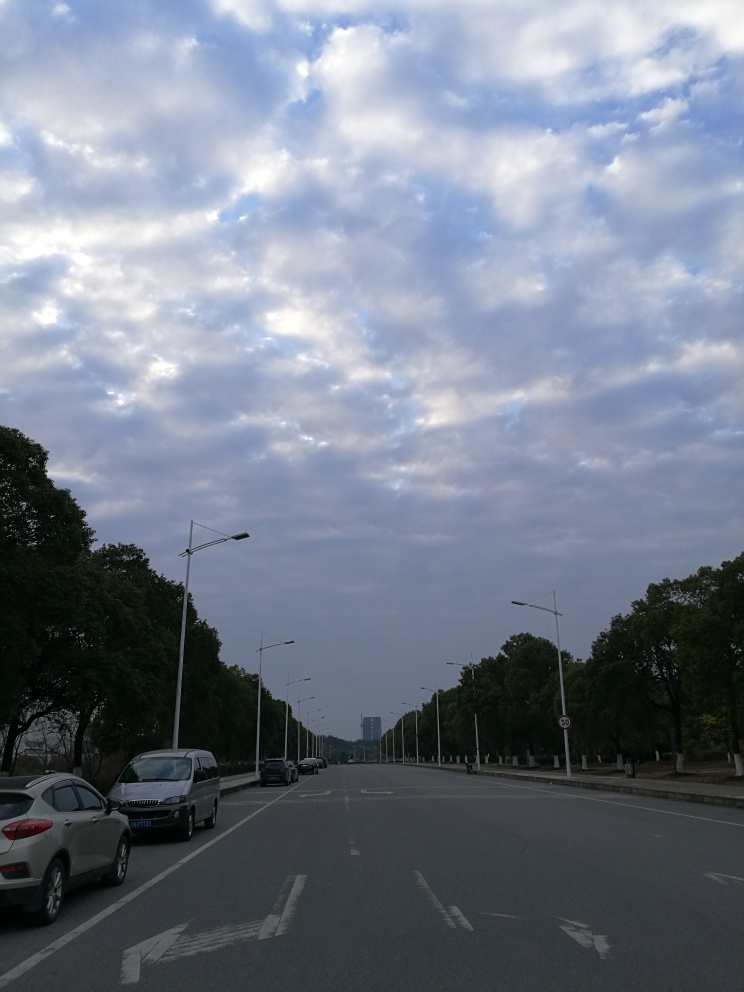How does the lighting in the photo affect the mood? The lighting in the photo appears soft and diffused, likely due to the overcast sky, which creates a calm and serene mood. There's a sense of tranquility in the scene, as the diffuse light doesn't cast harsh shadows or create stark contrasts. Are there any elements that indicate the time of day or season? The photo seems to be taken during twilight, which can be inferred from the slightly dim lighting and the cool tones of the sky. There are no leaves on the trees on the right, suggesting it could be late autumn or winter. 